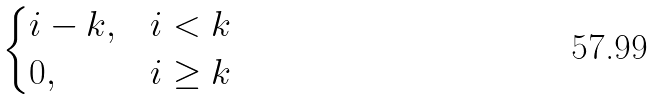Convert formula to latex. <formula><loc_0><loc_0><loc_500><loc_500>\begin{cases} i - k , & i < k \\ 0 , & i \geq k \end{cases}</formula> 